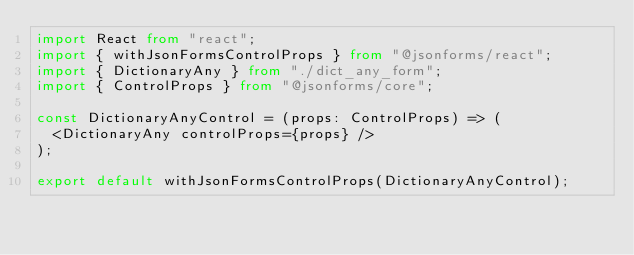<code> <loc_0><loc_0><loc_500><loc_500><_TypeScript_>import React from "react";
import { withJsonFormsControlProps } from "@jsonforms/react";
import { DictionaryAny } from "./dict_any_form";
import { ControlProps } from "@jsonforms/core";

const DictionaryAnyControl = (props: ControlProps) => (
  <DictionaryAny controlProps={props} />
);

export default withJsonFormsControlProps(DictionaryAnyControl);
</code> 